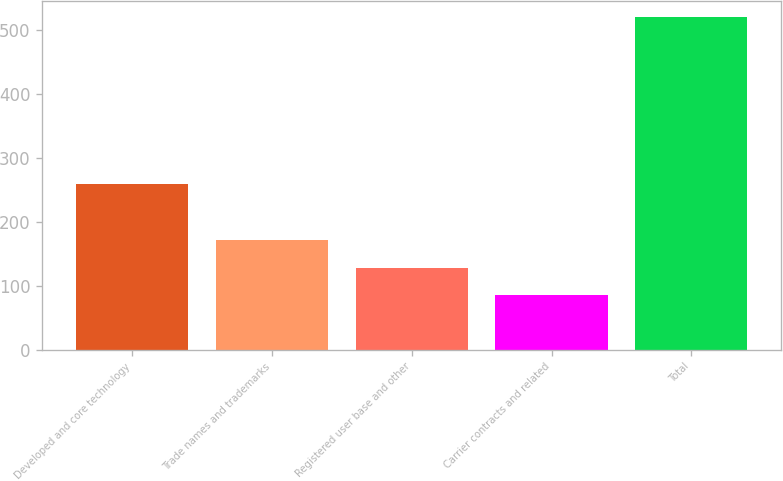Convert chart to OTSL. <chart><loc_0><loc_0><loc_500><loc_500><bar_chart><fcel>Developed and core technology<fcel>Trade names and trademarks<fcel>Registered user base and other<fcel>Carrier contracts and related<fcel>Total<nl><fcel>259<fcel>172<fcel>128.5<fcel>85<fcel>520<nl></chart> 